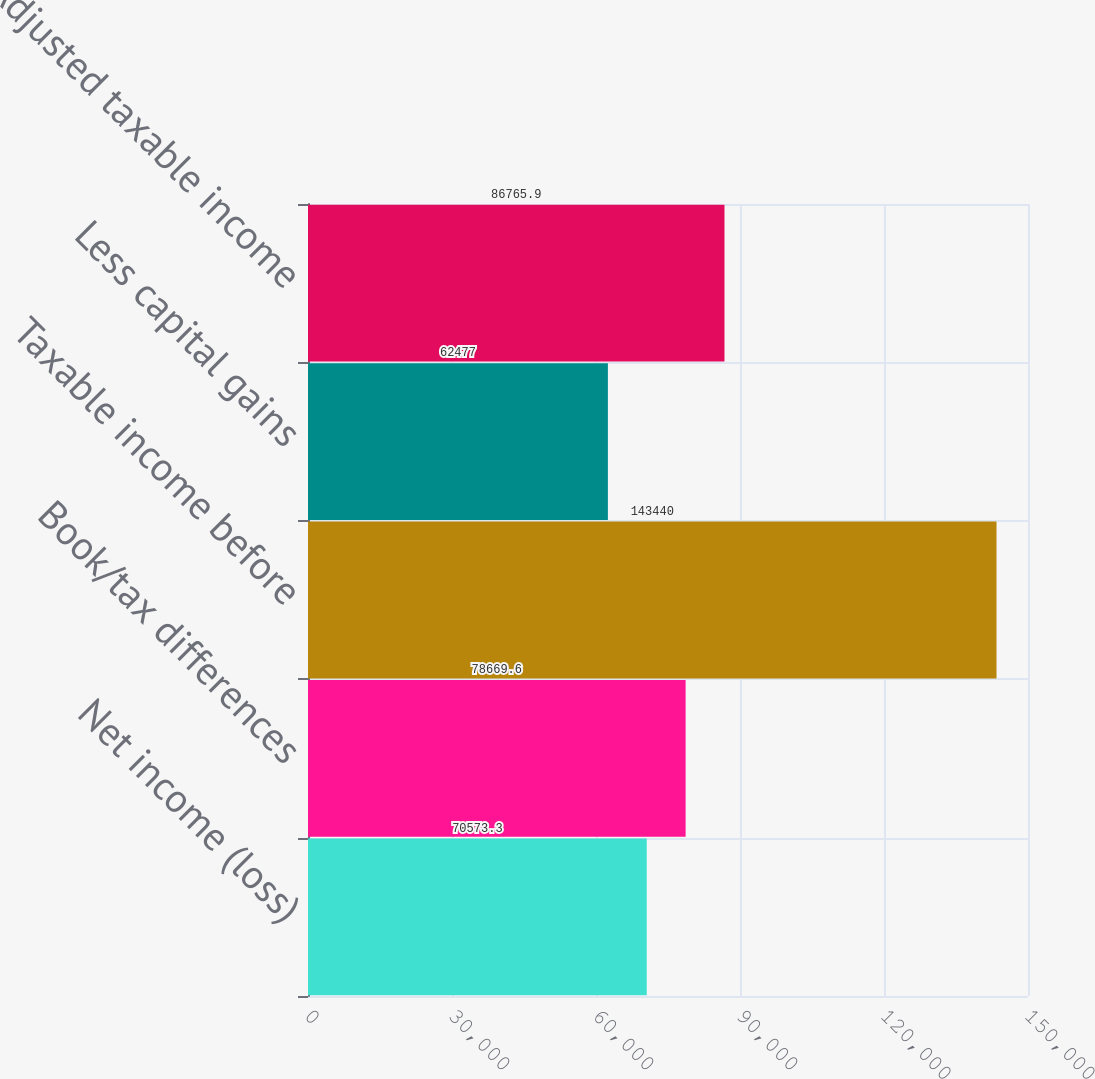Convert chart to OTSL. <chart><loc_0><loc_0><loc_500><loc_500><bar_chart><fcel>Net income (loss)<fcel>Book/tax differences<fcel>Taxable income before<fcel>Less capital gains<fcel>Adjusted taxable income<nl><fcel>70573.3<fcel>78669.6<fcel>143440<fcel>62477<fcel>86765.9<nl></chart> 